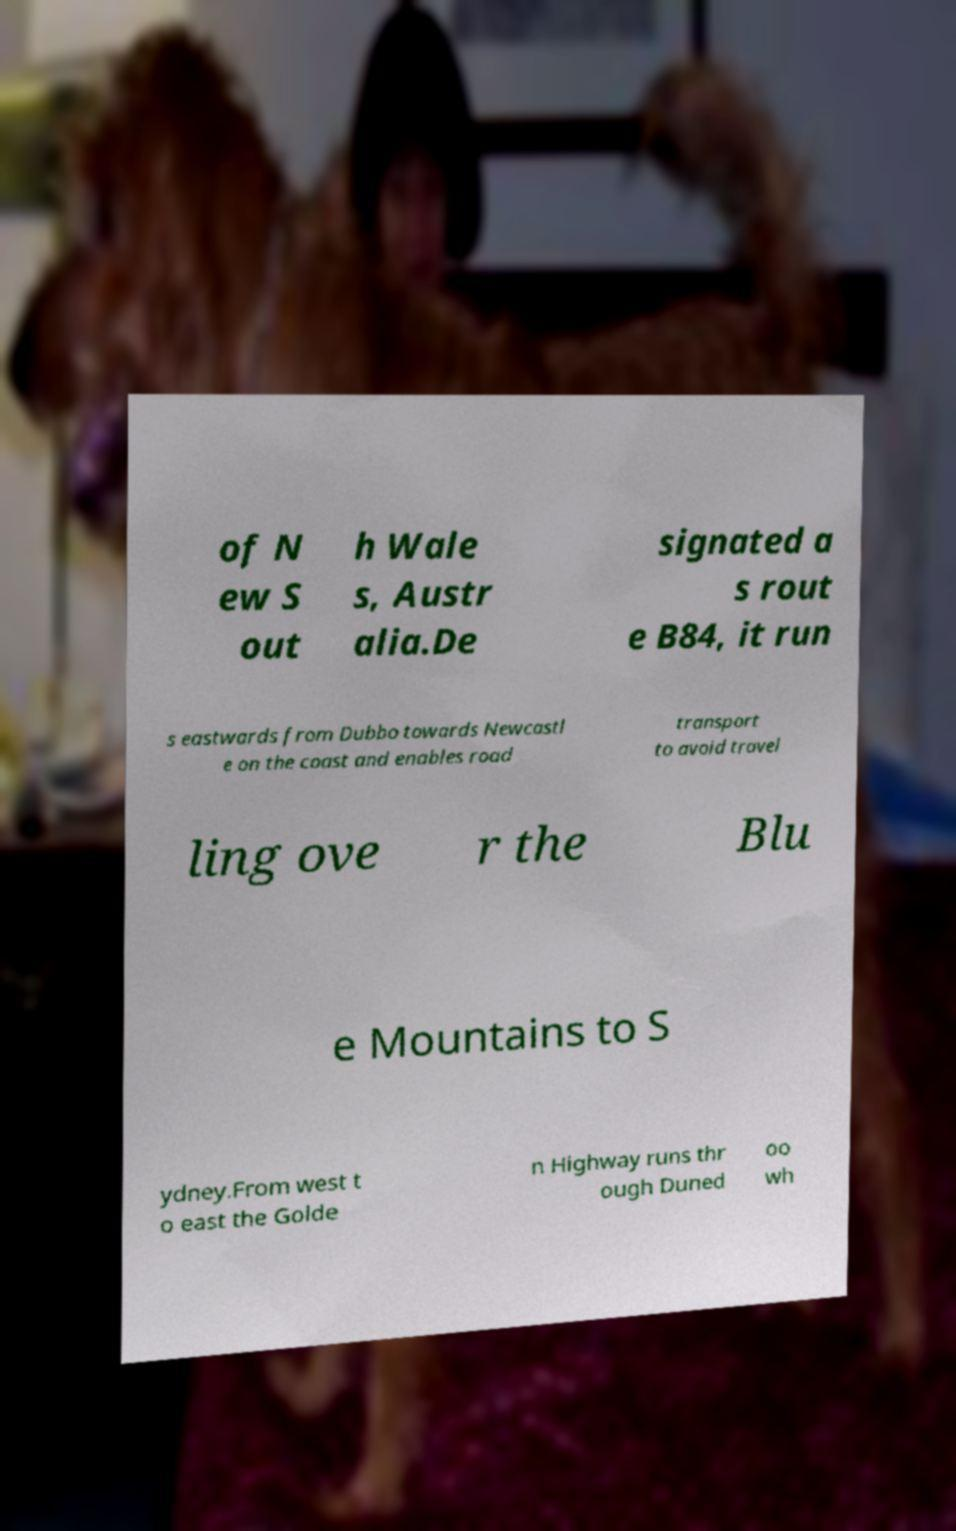Could you extract and type out the text from this image? of N ew S out h Wale s, Austr alia.De signated a s rout e B84, it run s eastwards from Dubbo towards Newcastl e on the coast and enables road transport to avoid travel ling ove r the Blu e Mountains to S ydney.From west t o east the Golde n Highway runs thr ough Duned oo wh 